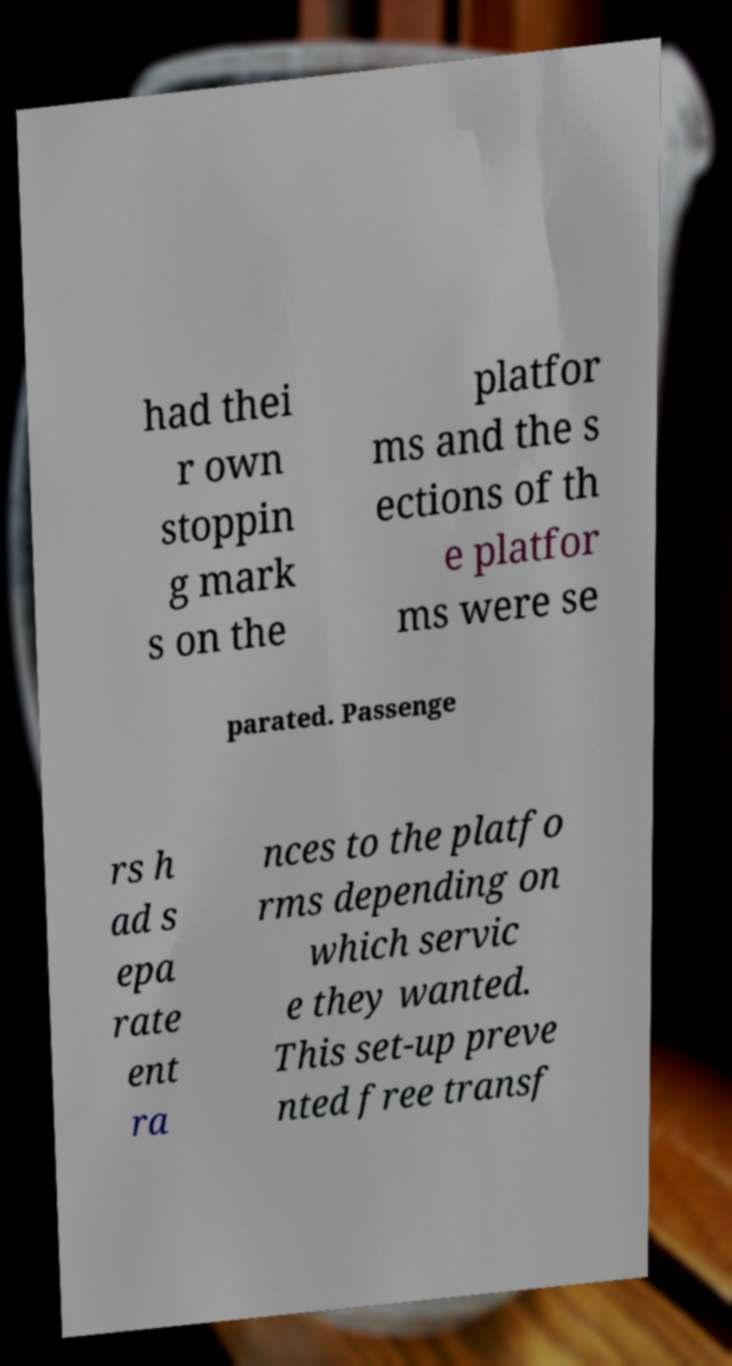For documentation purposes, I need the text within this image transcribed. Could you provide that? had thei r own stoppin g mark s on the platfor ms and the s ections of th e platfor ms were se parated. Passenge rs h ad s epa rate ent ra nces to the platfo rms depending on which servic e they wanted. This set-up preve nted free transf 